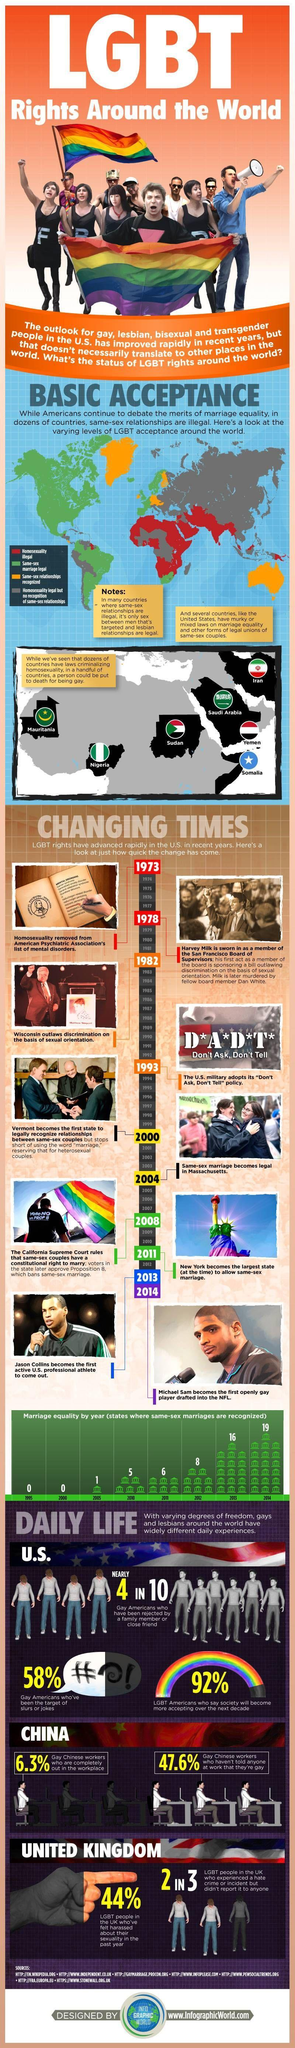Which year the same sex marriage became legal in Massachusetts?
Answer the question with a short phrase. 2004 When did Wisconsin outlaws discrimination on the basis of sexual orientation? 1982 How many states in the U.S recognized the same-sex marriages in the year 2011? 11 How many states in the U.S recognized the same-sex marriages in the year 2013? 16 What percentage of Gay Americans have been the  target of slurs or jokes? 58% 